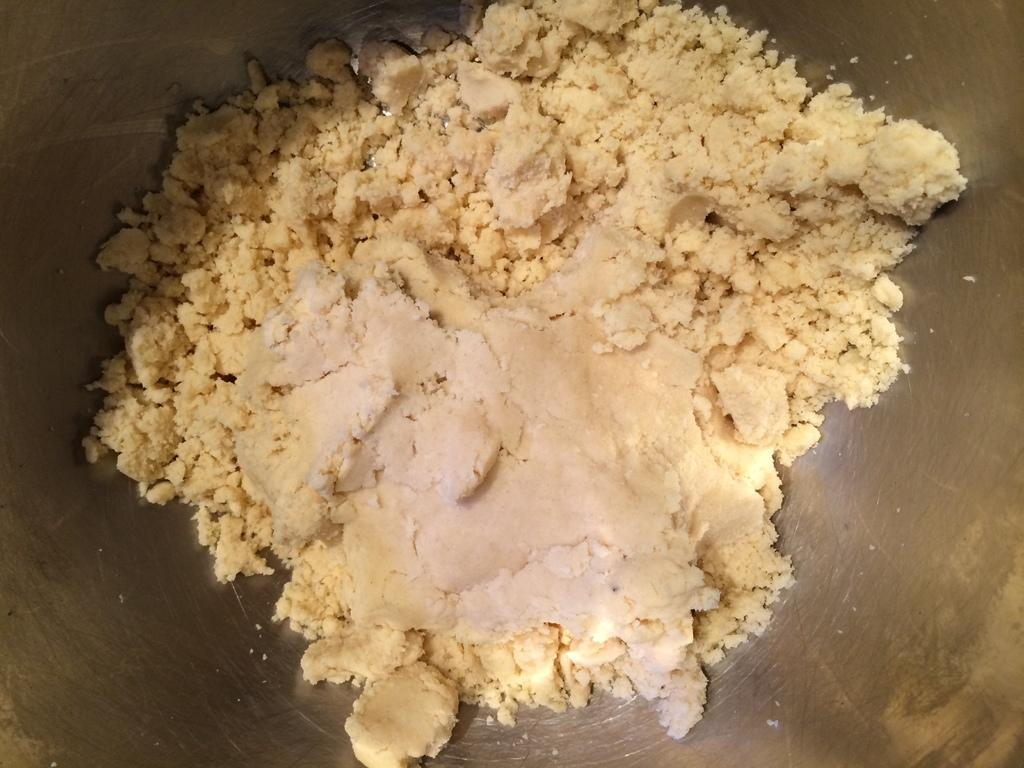What is the main object in the image? There is a pan in the image. What is inside the pan? The pan contains a powder and a mixture of another powder. Can you see a ship in the image? No, there is no ship present in the image. What is the end result of the mixture in the pan? The facts provided do not give information about the end result of the mixture in the pan, so it cannot be determined from the image. 